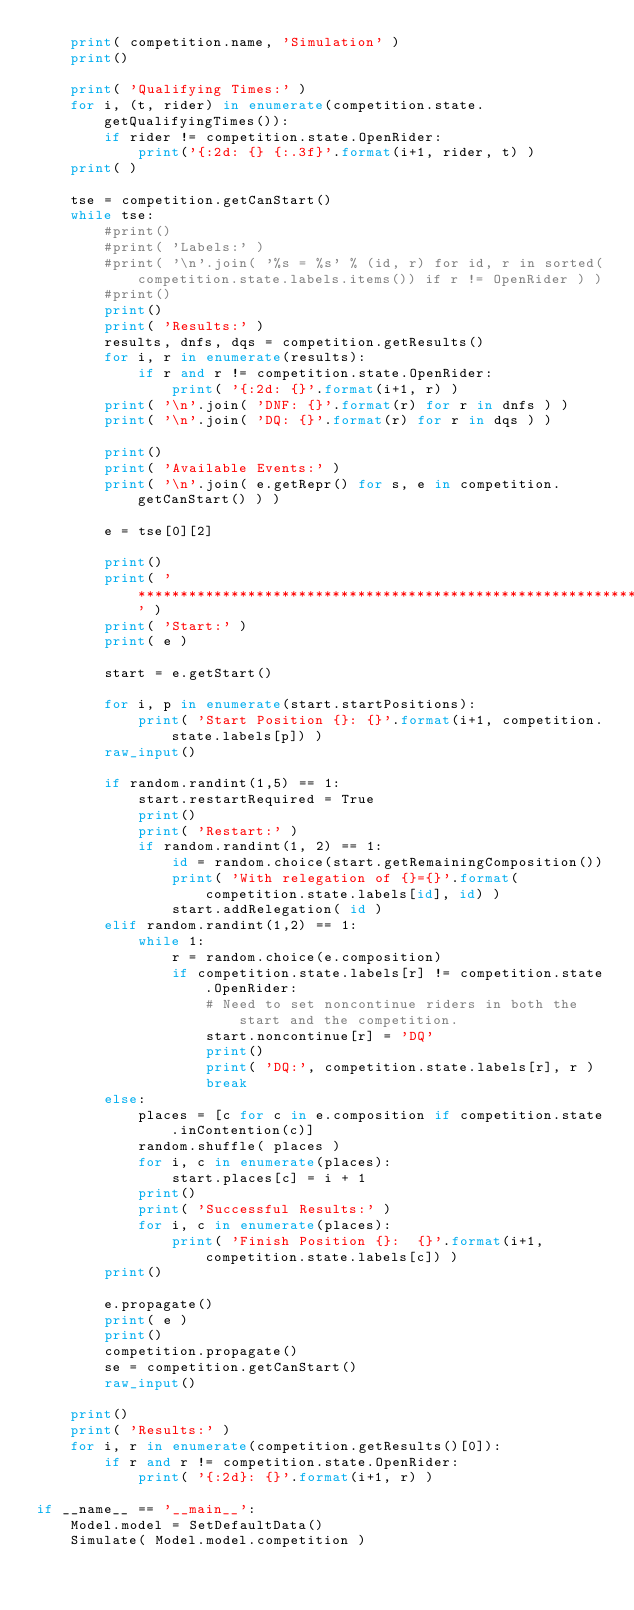Convert code to text. <code><loc_0><loc_0><loc_500><loc_500><_Python_>	print( competition.name, 'Simulation' )
	print()

	print( 'Qualifying Times:' )
	for i, (t, rider) in enumerate(competition.state.getQualifyingTimes()):
		if rider != competition.state.OpenRider:
			print('{:2d: {} {:.3f}'.format(i+1, rider, t) )
	print( )
	
	tse = competition.getCanStart()
	while tse:
		#print()
		#print( 'Labels:' )
		#print( '\n'.join( '%s = %s' % (id, r) for id, r in sorted(competition.state.labels.items()) if r != OpenRider ) )
		#print()
		print()
		print( 'Results:' )
		results, dnfs, dqs = competition.getResults()
		for i, r in enumerate(results):
			if r and r != competition.state.OpenRider:
				print( '{:2d: {}'.format(i+1, r) )
		print( '\n'.join( 'DNF: {}'.format(r) for r in dnfs ) )
		print( '\n'.join( 'DQ: {}'.format(r) for r in dqs ) )
			
		print()
		print( 'Available Events:' )
		print( '\n'.join( e.getRepr() for s, e in competition.getCanStart() ) )
		
		e = tse[0][2]
		
		print()
		print( '******************************************************************************' )
		print( 'Start:' )
		print( e )
		
		start = e.getStart()
		
		for i, p in enumerate(start.startPositions):
			print( 'Start Position {}: {}'.format(i+1, competition.state.labels[p]) )
		raw_input()
		
		if random.randint(1,5) == 1:
			start.restartRequired = True
			print()
			print( 'Restart:' )
			if random.randint(1, 2) == 1:
				id = random.choice(start.getRemainingComposition())
				print( 'With relegation of {}={}'.format(competition.state.labels[id], id) )
				start.addRelegation( id )
		elif random.randint(1,2) == 1:
			while 1:
				r = random.choice(e.composition)
				if competition.state.labels[r] != competition.state.OpenRider:
					# Need to set noncontinue riders in both the start and the competition.
					start.noncontinue[r] = 'DQ'
					print()
					print( 'DQ:', competition.state.labels[r], r )
					break
		else:
			places = [c for c in e.composition if competition.state.inContention(c)]
			random.shuffle( places )
			for i, c in enumerate(places):
				start.places[c] = i + 1
			print()
			print( 'Successful Results:' )
			for i, c in enumerate(places):
				print( 'Finish Position {}:  {}'.format(i+1, competition.state.labels[c]) )
		print()
		
		e.propagate()
		print( e )
		print()
		competition.propagate()
		se = competition.getCanStart()
		raw_input()
			
	print()
	print( 'Results:' )
	for i, r in enumerate(competition.getResults()[0]):
		if r and r != competition.state.OpenRider:
			print( '{:2d}: {}'.format(i+1, r) )

if __name__ == '__main__':
	Model.model = SetDefaultData()
	Simulate( Model.model.competition )
</code> 